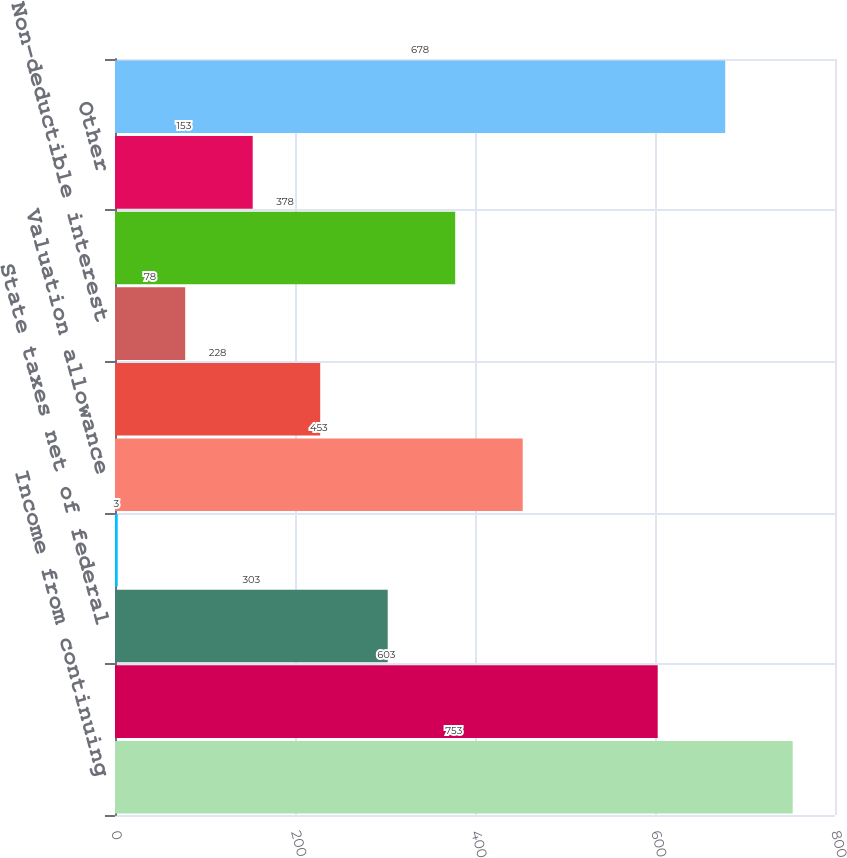Convert chart to OTSL. <chart><loc_0><loc_0><loc_500><loc_500><bar_chart><fcel>Income from continuing<fcel>Tax at 35<fcel>State taxes net of federal<fcel>Foreign operations<fcel>Valuation allowance<fcel>Foreign earnings<fcel>Non-deductible interest<fcel>Interest accrued on uncertain<fcel>Other<fcel>Income tax expense<nl><fcel>753<fcel>603<fcel>303<fcel>3<fcel>453<fcel>228<fcel>78<fcel>378<fcel>153<fcel>678<nl></chart> 